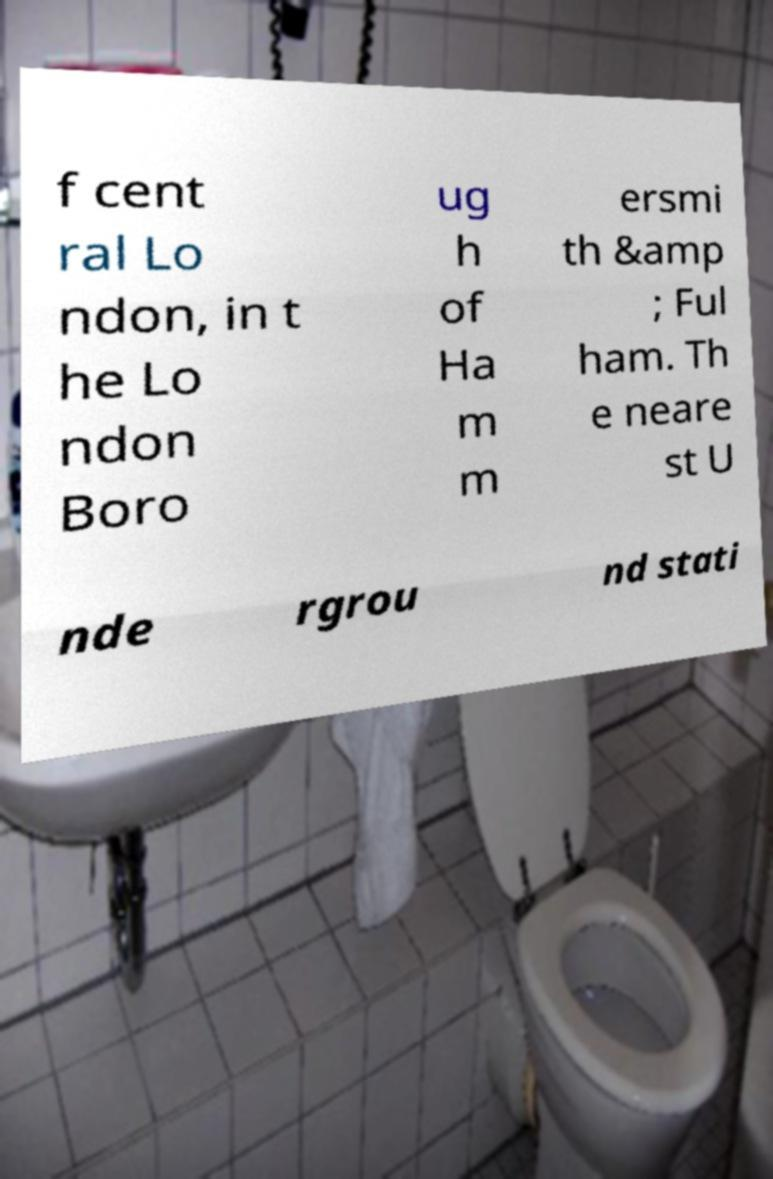Can you read and provide the text displayed in the image?This photo seems to have some interesting text. Can you extract and type it out for me? f cent ral Lo ndon, in t he Lo ndon Boro ug h of Ha m m ersmi th &amp ; Ful ham. Th e neare st U nde rgrou nd stati 